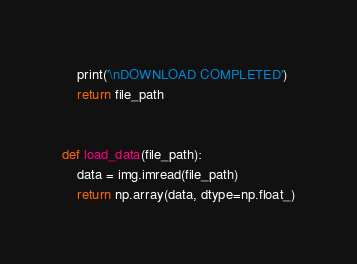<code> <loc_0><loc_0><loc_500><loc_500><_Python_>    print('\nDOWNLOAD COMPLETED')
    return file_path


def load_data(file_path):
    data = img.imread(file_path)
    return np.array(data, dtype=np.float_)
</code> 